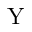<formula> <loc_0><loc_0><loc_500><loc_500>Y</formula> 